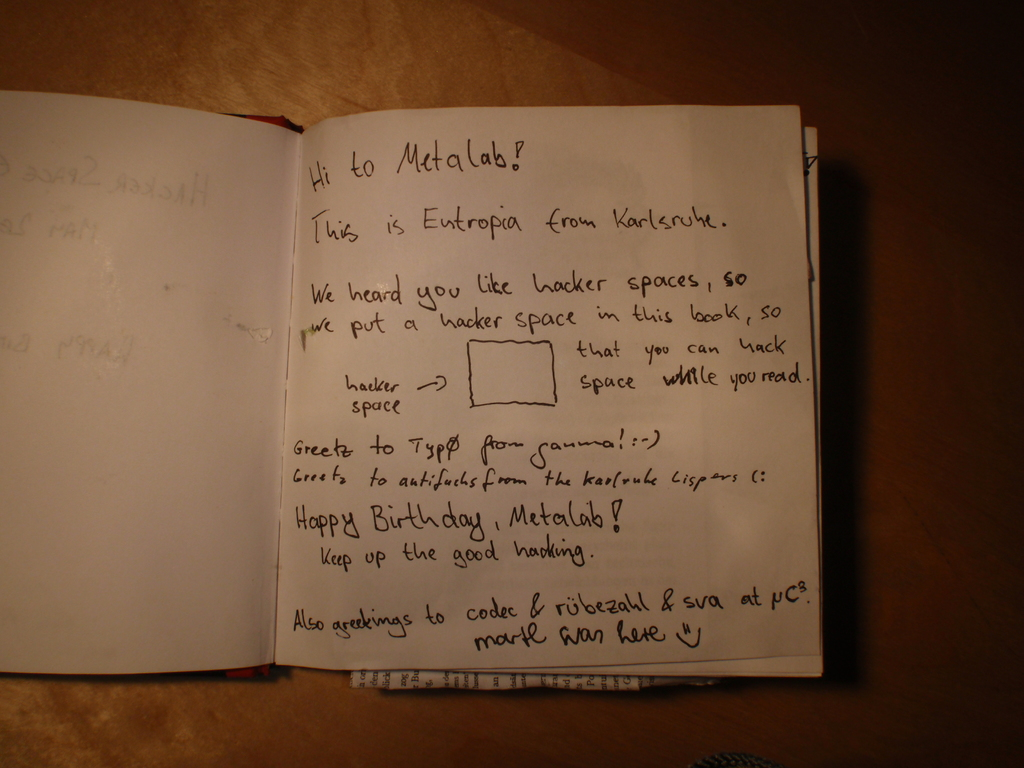What details can you provide about the handwriting style seen in the note? The handwriting in the note is informal and personable, characterized by a mix of cursive and print styles. It uses all capital letters for emphasis on certain words, adding a dynamic tone to the message. The hand appears steady, suggesting the writer was comfortable and unhurried while writing, which contributes to the note's friendly and inviting feel. 